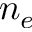<formula> <loc_0><loc_0><loc_500><loc_500>n _ { e }</formula> 